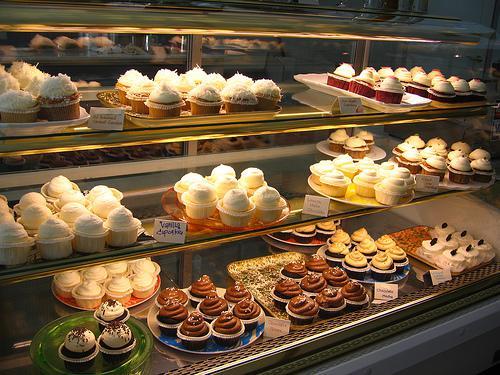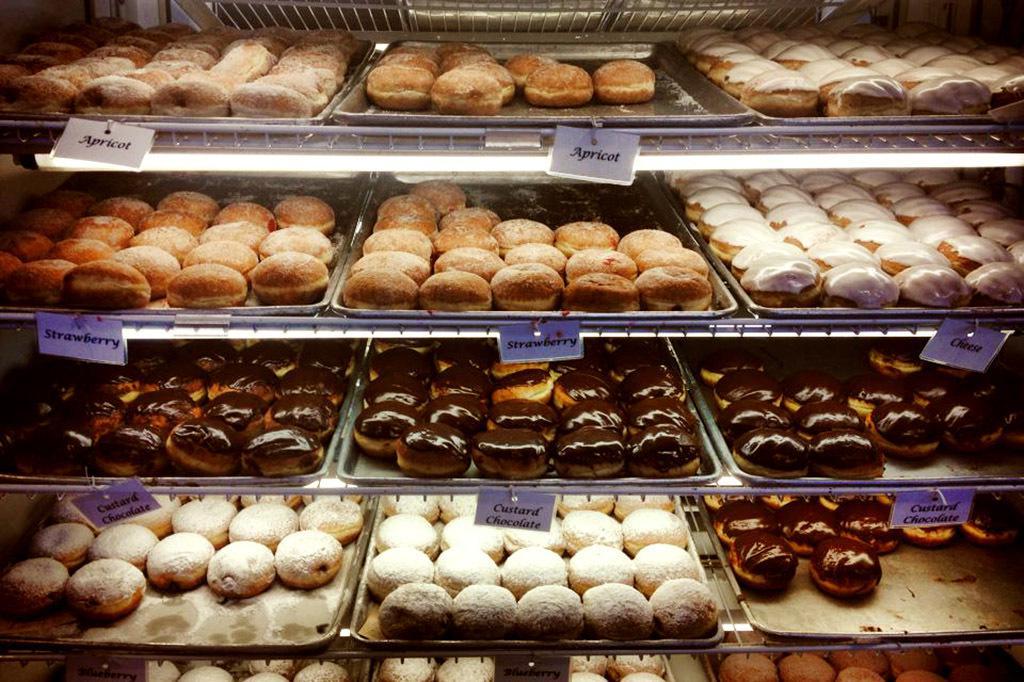The first image is the image on the left, the second image is the image on the right. Analyze the images presented: Is the assertion "At least one person is near bread products in one image." valid? Answer yes or no. No. The first image is the image on the left, the second image is the image on the right. For the images shown, is this caption "There is at least one purple label in one of the images." true? Answer yes or no. Yes. The first image is the image on the left, the second image is the image on the right. Assess this claim about the two images: "There are many loaves of bread in the image on the right". Correct or not? Answer yes or no. No. 